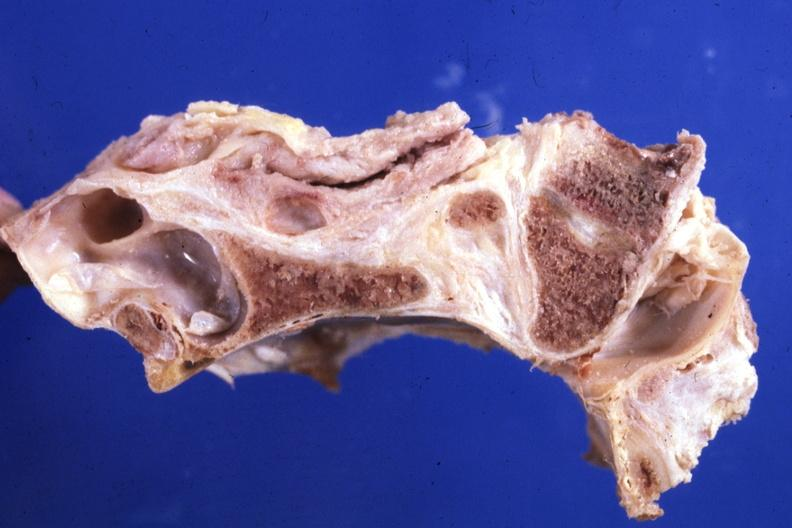what is present?
Answer the question using a single word or phrase. Bone, calvarium 